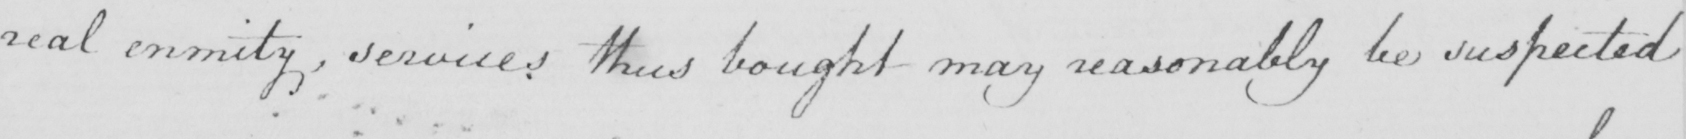Can you tell me what this handwritten text says? real enmity , services thus bought may reasonably be suspected 